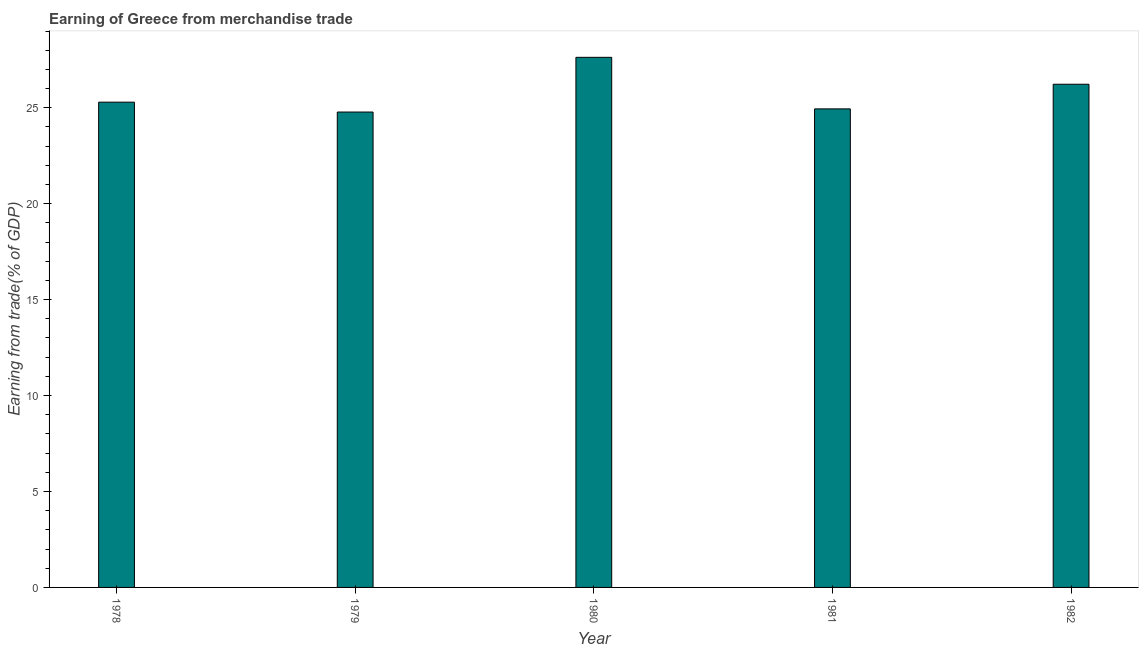Does the graph contain any zero values?
Make the answer very short. No. What is the title of the graph?
Keep it short and to the point. Earning of Greece from merchandise trade. What is the label or title of the X-axis?
Your response must be concise. Year. What is the label or title of the Y-axis?
Give a very brief answer. Earning from trade(% of GDP). What is the earning from merchandise trade in 1978?
Keep it short and to the point. 25.29. Across all years, what is the maximum earning from merchandise trade?
Provide a succinct answer. 27.63. Across all years, what is the minimum earning from merchandise trade?
Provide a short and direct response. 24.78. In which year was the earning from merchandise trade maximum?
Give a very brief answer. 1980. In which year was the earning from merchandise trade minimum?
Give a very brief answer. 1979. What is the sum of the earning from merchandise trade?
Provide a succinct answer. 128.86. What is the difference between the earning from merchandise trade in 1978 and 1979?
Offer a very short reply. 0.52. What is the average earning from merchandise trade per year?
Your answer should be very brief. 25.77. What is the median earning from merchandise trade?
Offer a terse response. 25.29. In how many years, is the earning from merchandise trade greater than 14 %?
Your answer should be compact. 5. What is the ratio of the earning from merchandise trade in 1978 to that in 1980?
Make the answer very short. 0.92. Is the earning from merchandise trade in 1979 less than that in 1981?
Offer a very short reply. Yes. What is the difference between the highest and the second highest earning from merchandise trade?
Provide a succinct answer. 1.4. What is the difference between the highest and the lowest earning from merchandise trade?
Give a very brief answer. 2.85. How many years are there in the graph?
Make the answer very short. 5. What is the Earning from trade(% of GDP) in 1978?
Make the answer very short. 25.29. What is the Earning from trade(% of GDP) in 1979?
Ensure brevity in your answer.  24.78. What is the Earning from trade(% of GDP) of 1980?
Your answer should be compact. 27.63. What is the Earning from trade(% of GDP) of 1981?
Your answer should be compact. 24.94. What is the Earning from trade(% of GDP) in 1982?
Ensure brevity in your answer.  26.23. What is the difference between the Earning from trade(% of GDP) in 1978 and 1979?
Ensure brevity in your answer.  0.51. What is the difference between the Earning from trade(% of GDP) in 1978 and 1980?
Your answer should be very brief. -2.34. What is the difference between the Earning from trade(% of GDP) in 1978 and 1981?
Your response must be concise. 0.35. What is the difference between the Earning from trade(% of GDP) in 1978 and 1982?
Your response must be concise. -0.93. What is the difference between the Earning from trade(% of GDP) in 1979 and 1980?
Your answer should be very brief. -2.85. What is the difference between the Earning from trade(% of GDP) in 1979 and 1981?
Give a very brief answer. -0.17. What is the difference between the Earning from trade(% of GDP) in 1979 and 1982?
Make the answer very short. -1.45. What is the difference between the Earning from trade(% of GDP) in 1980 and 1981?
Keep it short and to the point. 2.69. What is the difference between the Earning from trade(% of GDP) in 1980 and 1982?
Your answer should be compact. 1.4. What is the difference between the Earning from trade(% of GDP) in 1981 and 1982?
Ensure brevity in your answer.  -1.28. What is the ratio of the Earning from trade(% of GDP) in 1978 to that in 1979?
Keep it short and to the point. 1.02. What is the ratio of the Earning from trade(% of GDP) in 1978 to that in 1980?
Provide a succinct answer. 0.92. What is the ratio of the Earning from trade(% of GDP) in 1978 to that in 1981?
Offer a very short reply. 1.01. What is the ratio of the Earning from trade(% of GDP) in 1979 to that in 1980?
Give a very brief answer. 0.9. What is the ratio of the Earning from trade(% of GDP) in 1979 to that in 1982?
Make the answer very short. 0.94. What is the ratio of the Earning from trade(% of GDP) in 1980 to that in 1981?
Your answer should be compact. 1.11. What is the ratio of the Earning from trade(% of GDP) in 1980 to that in 1982?
Your response must be concise. 1.05. What is the ratio of the Earning from trade(% of GDP) in 1981 to that in 1982?
Make the answer very short. 0.95. 